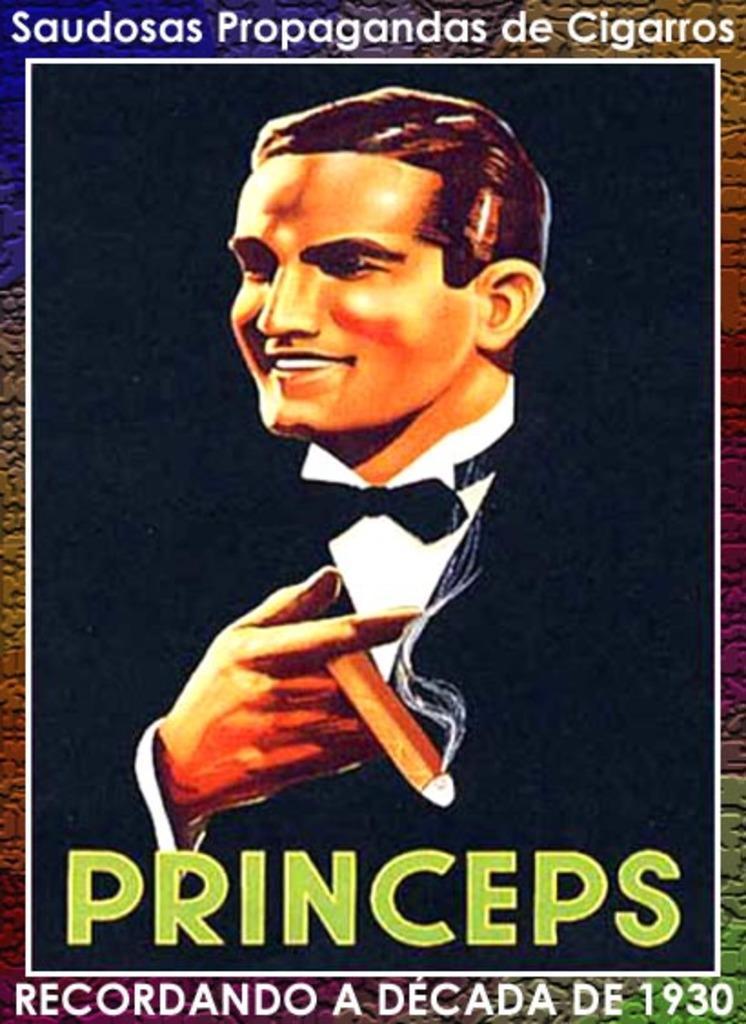Can you describe this image briefly? In this image, we can see a poster, on that poster we can see a man and some text on the poster. 